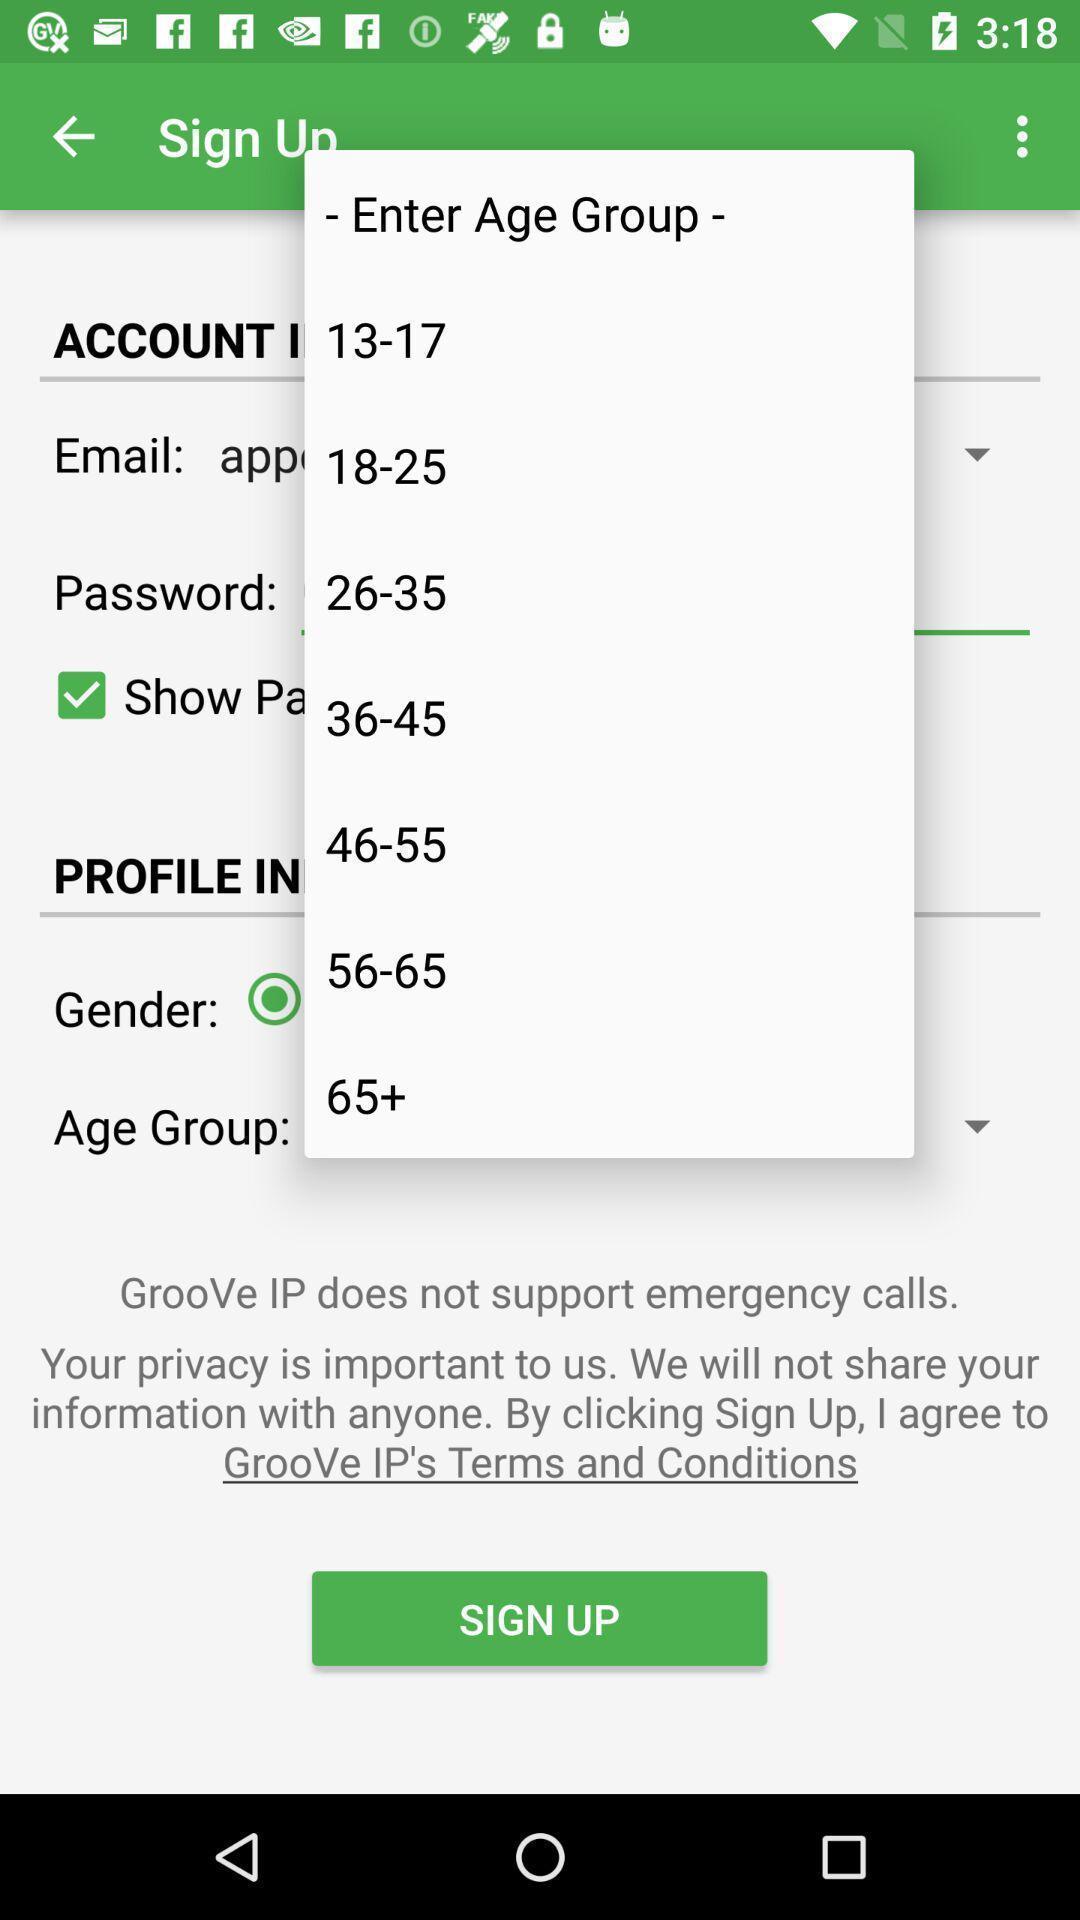Tell me about the visual elements in this screen capture. Sign up page. 